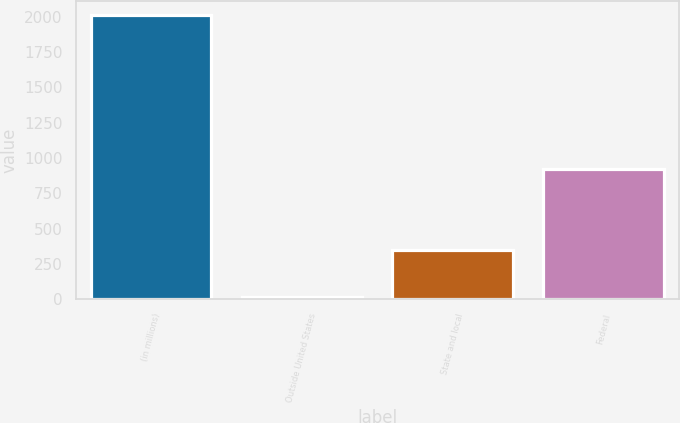Convert chart. <chart><loc_0><loc_0><loc_500><loc_500><bar_chart><fcel>(in millions)<fcel>Outside United States<fcel>State and local<fcel>Federal<nl><fcel>2012<fcel>16<fcel>348<fcel>920<nl></chart> 